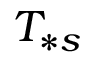<formula> <loc_0><loc_0><loc_500><loc_500>T _ { \ast s }</formula> 